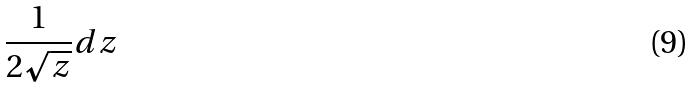<formula> <loc_0><loc_0><loc_500><loc_500>\frac { 1 } { 2 \sqrt { z } } d z</formula> 